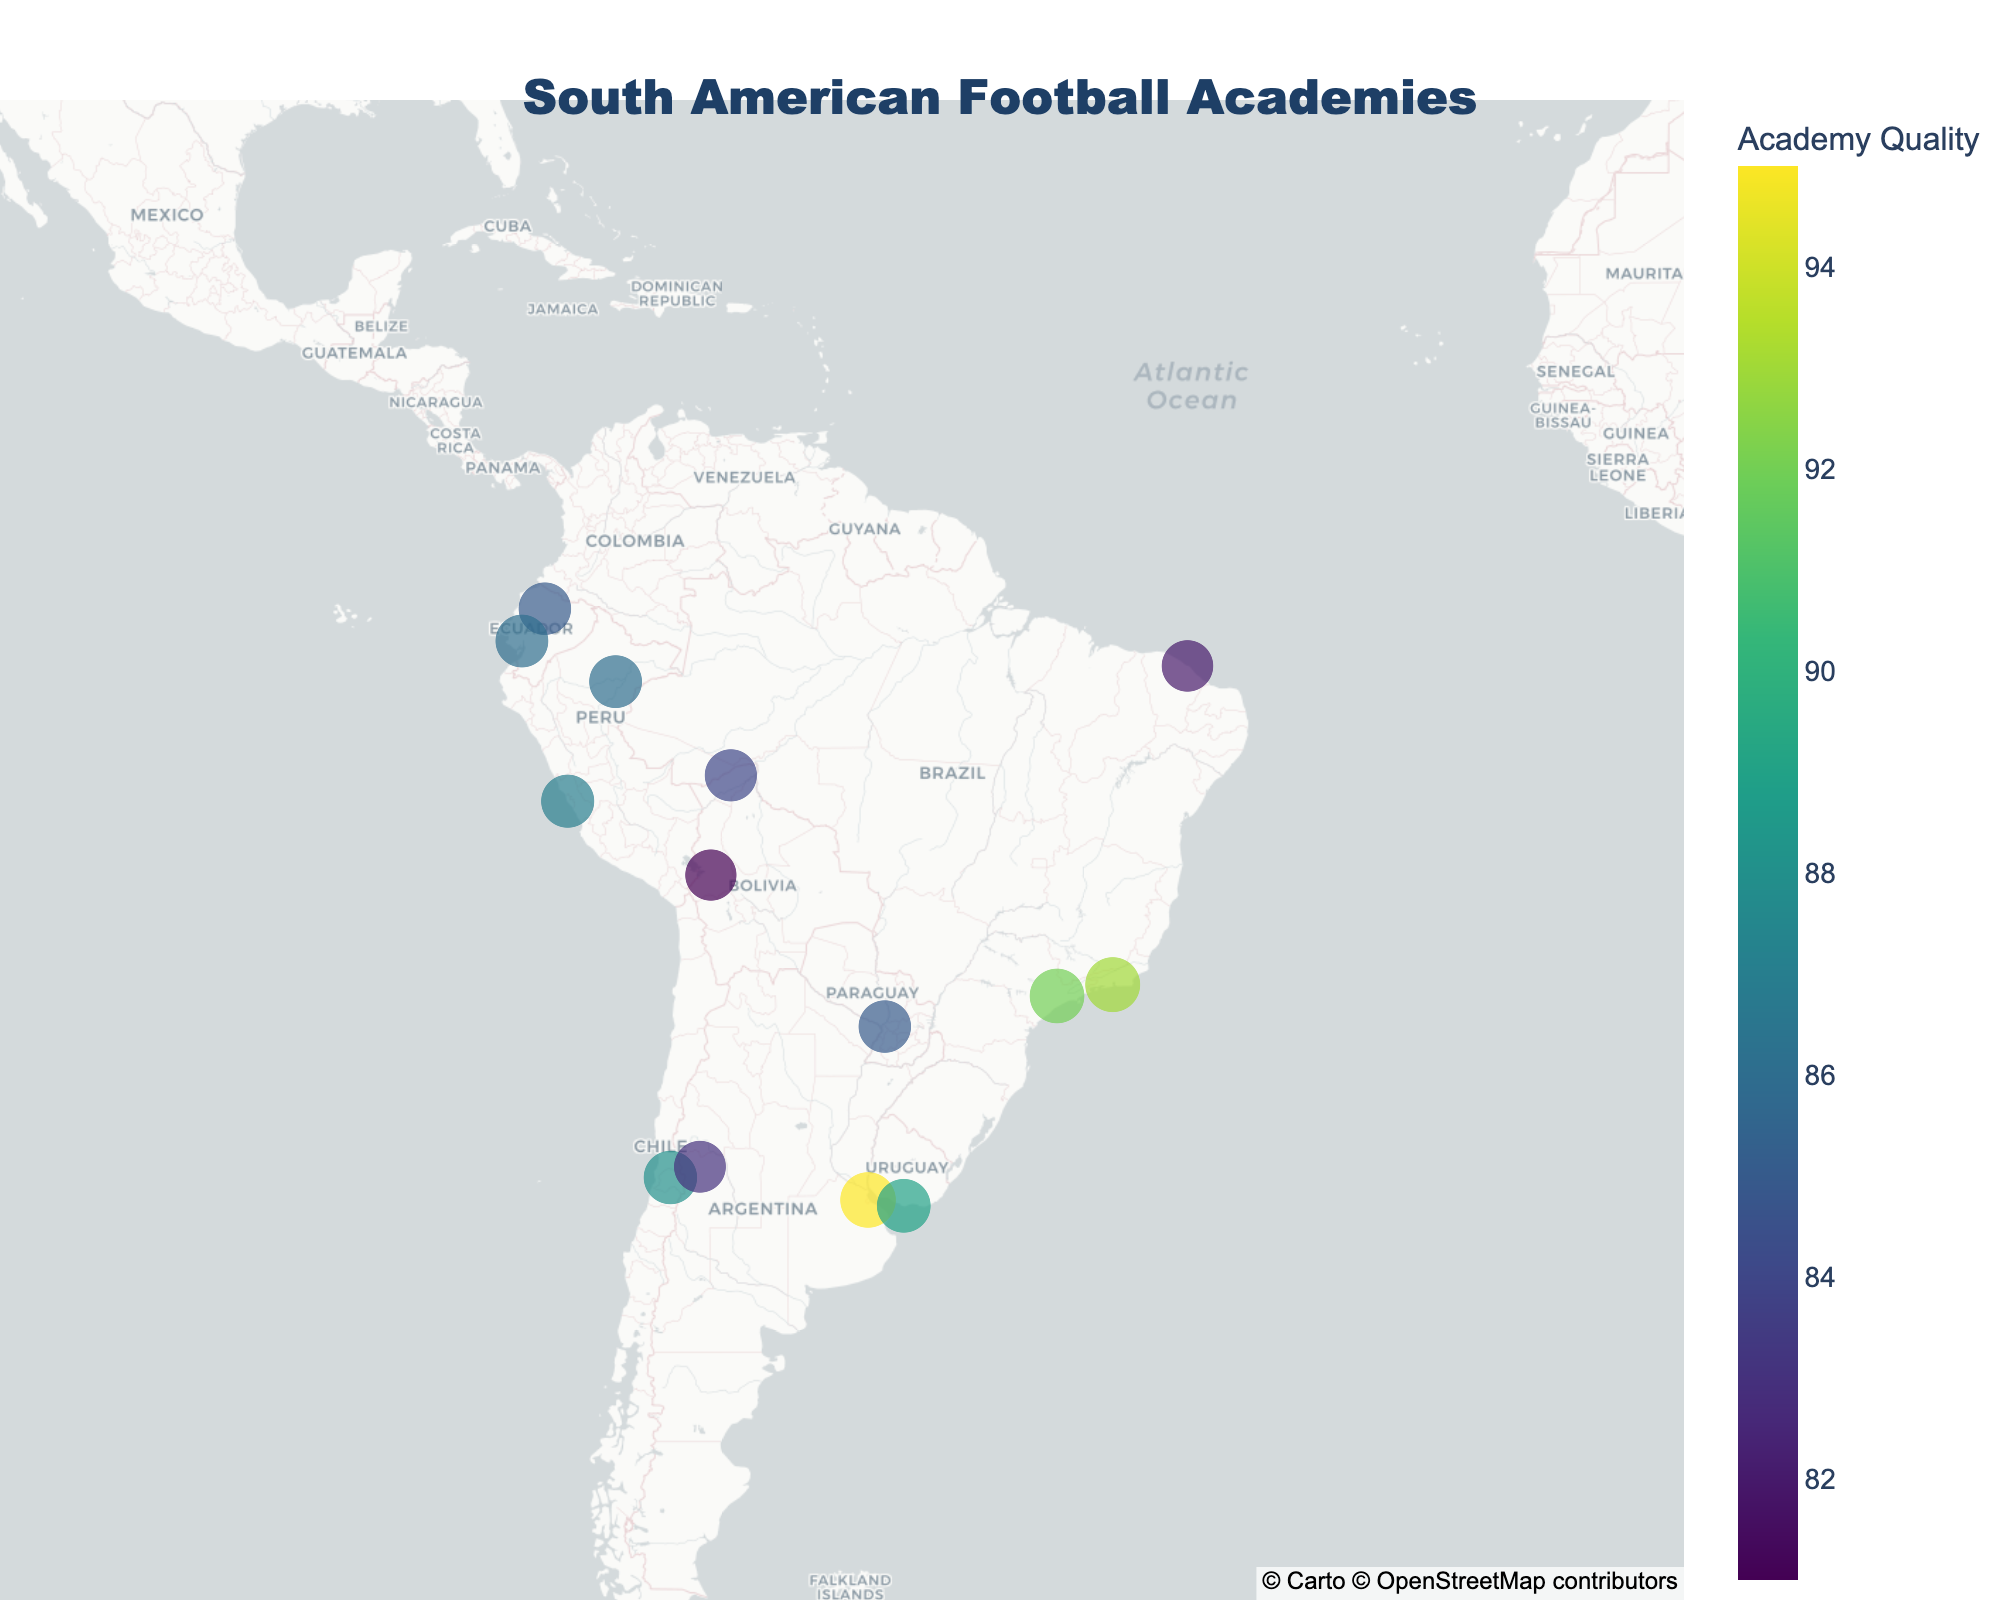What is the title of the plot? The title is prominently displayed at the top of the figure and can be read directly from the plot.
Answer: South American Football Academies How many football academies are displayed in the heatmap? Count the number of scattered points representing the football academies on the map.
Answer: 14 Which country has the most football academies represented in the heatmap? Look for the countries indicated for each academy and count how many points are in each country. Brazil has the most academies (São Paulo FC, Flamengo Youth Setup, and Fortaleza EC).
Answer: Brazil Which football academy has the highest quality rating? Identify the point with the largest size and highest color intensity representing the highest quality rating. The academy with the highest rating is River Plate Youth Academy.
Answer: River Plate Youth Academy What is the quality rating of the football academy located in Uruguay? Locate the academy in Uruguay on the map by its geographical position and read its quality rating from the hover data or color intensity and size.
Answer: 89 What is the average quality rating of football academies in Brazil? Identify all Brazilian academies (São Paulo FC, Flamengo Youth Setup, and Fortaleza EC), sum their quality ratings (92 + 93 + 82 = 267), and divide by the number of academies to find the average.
Answer: 89 Which football academy is closest to the center of the map (-15 latitude, -60 longitude)? Visually inspect the location of each academy concerning the map's center and identify the nearest one.
Answer: São Paulo FC Academy Are there more football academies above or below the equator? Determine the location of each academy relative to the equator (latitude 0) and count the number of academies above and below it.
Answer: Below Which country has a football academy with a quality rating equal to 86? Check the quality rating of each academy and identify the country/countries with an academy rated 86. Both Colombia (Millonarios FC Youth System) and Ecuador (Barcelona SC Youth System) match this criterion.
Answer: Colombia and Ecuador What is the difference in quality rating between the highest and lowest-rated academies? Identify the highest (95 - River Plate Youth Academy) and lowest (81 - Bolívar Youth Development) quality ratings and subtract the lower from the higher (95 - 81).
Answer: 14 